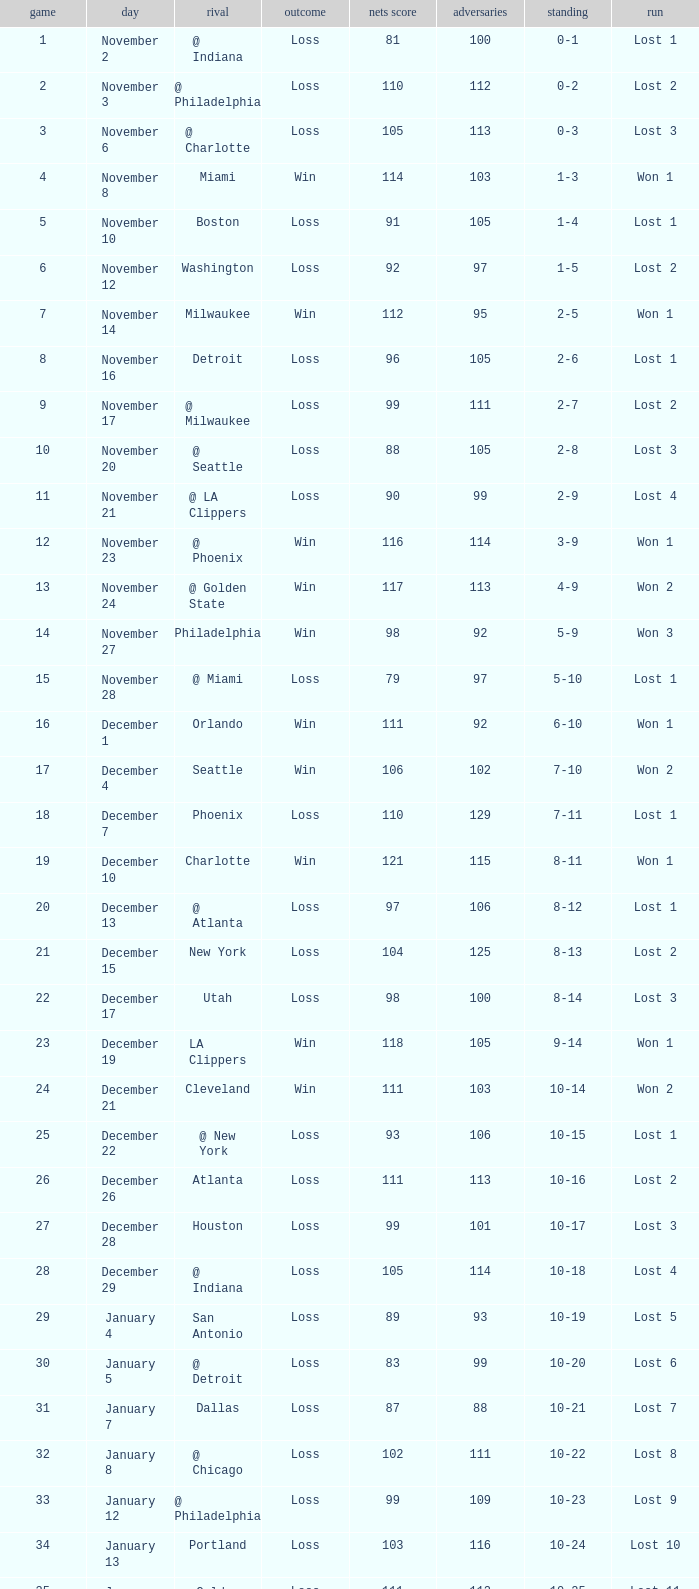In which game did the opponent score more than 103 and the record was 1-3? None. 